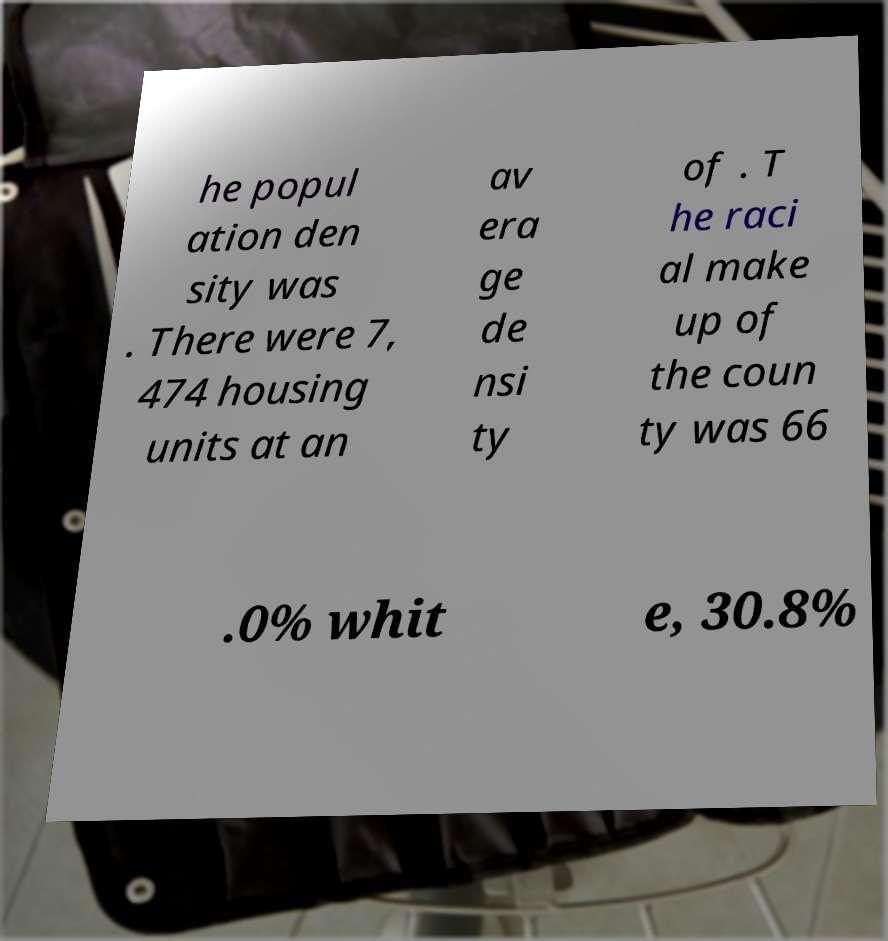There's text embedded in this image that I need extracted. Can you transcribe it verbatim? he popul ation den sity was . There were 7, 474 housing units at an av era ge de nsi ty of . T he raci al make up of the coun ty was 66 .0% whit e, 30.8% 